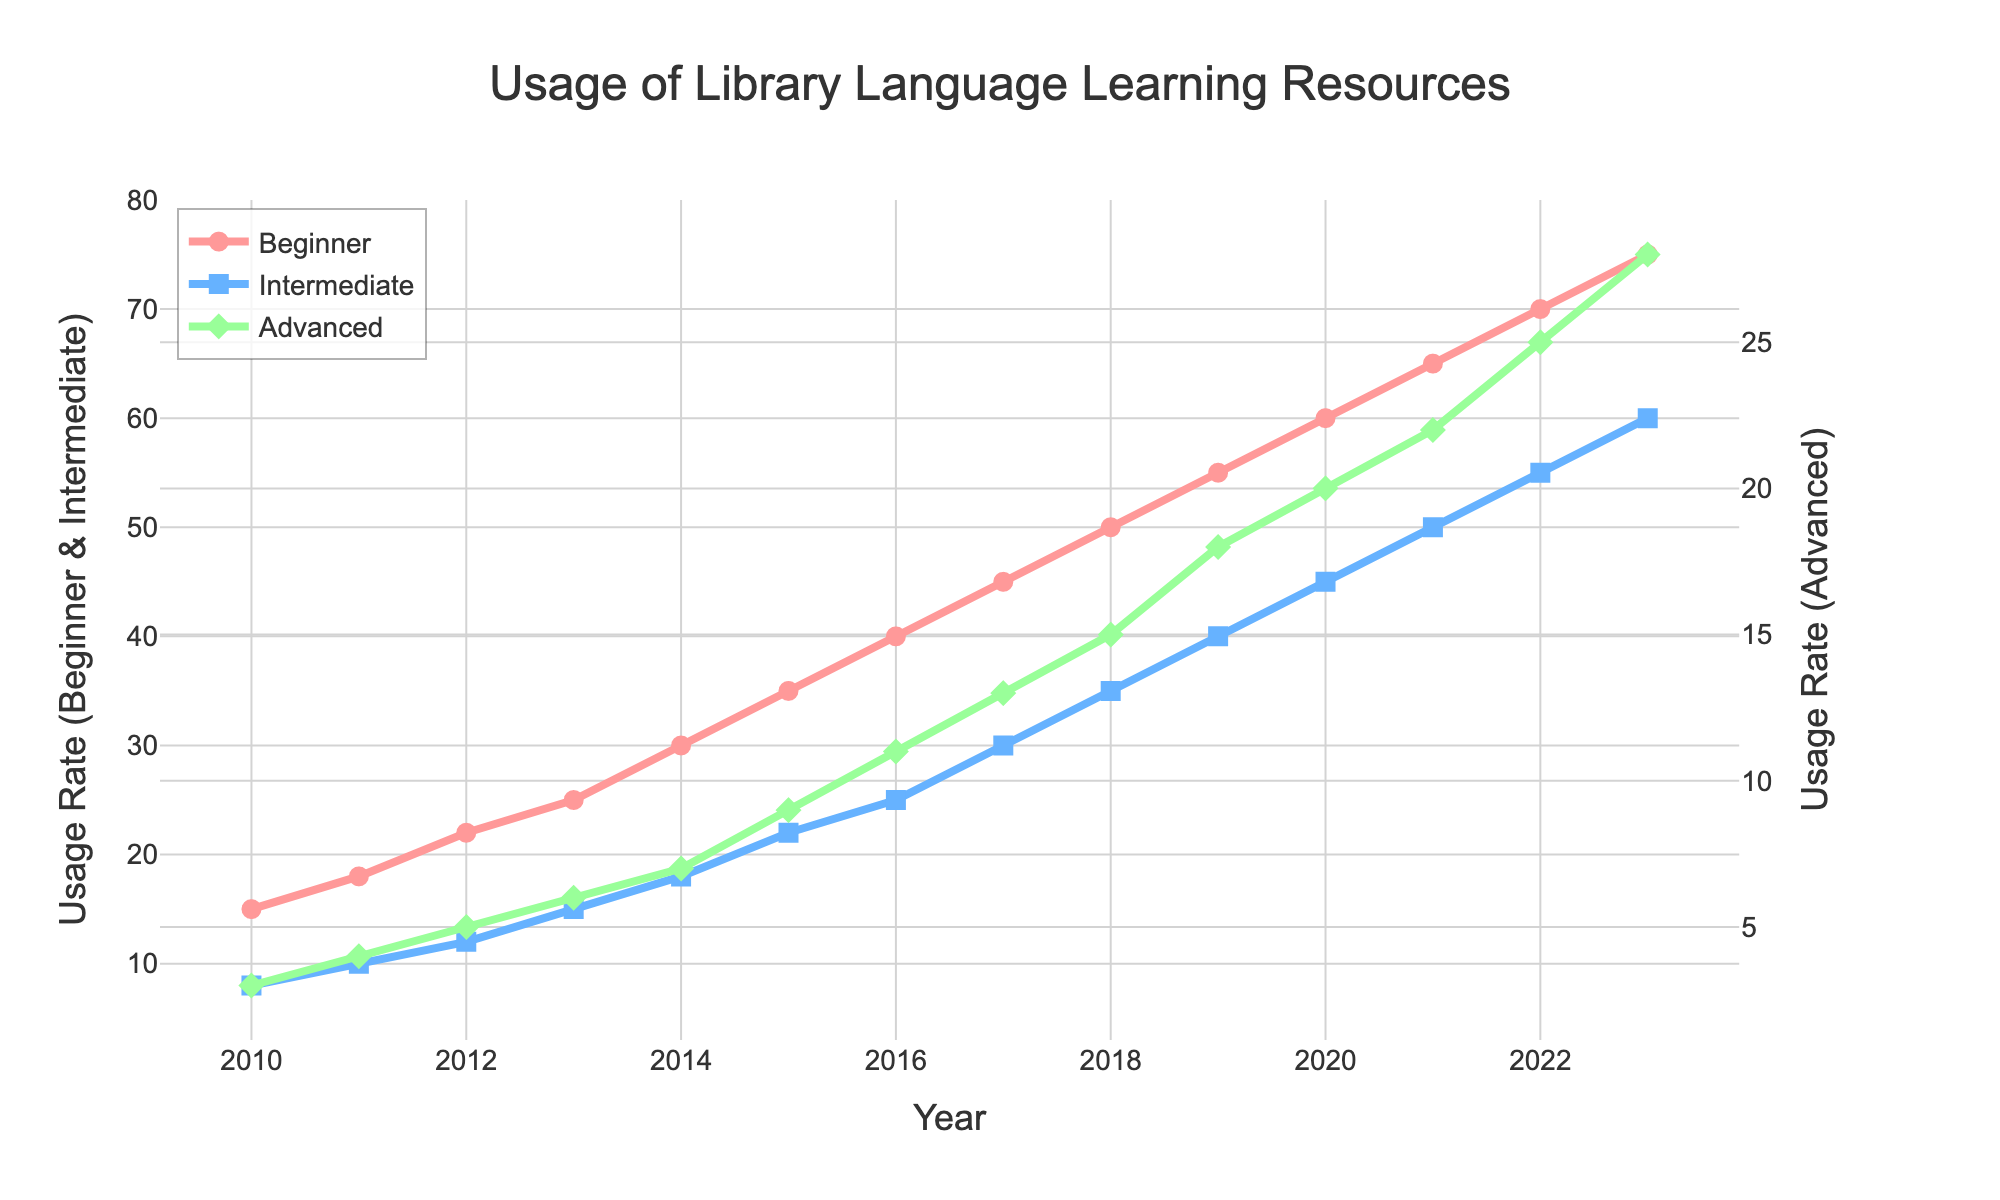What trend is observed in the Beginner proficiency level from 2010 to 2023? The Beginner proficiency level shows a consistent increase from 2010 (with a usage rate of 15) to 2023 (with a usage rate of 75).
Answer: Consistent increase Which year shows the highest usage rate for the Intermediate proficiency level? The year 2023 shows the highest usage rate for the Intermediate proficiency level, reaching 60.
Answer: 2023 How does the usage rate of the Advanced proficiency level in 2023 compare to that in 2010? The usage rate of the Advanced proficiency level in 2023 is 28, which is significantly higher than the usage rate in 2010, which was 3.
Answer: Significantly higher What is the difference in usage rates between the Beginner and Intermediate proficiency levels in 2020? In 2020, the usage rate for Beginner is 60 and for Intermediate is 45. The difference is 60 - 45 = 15.
Answer: 15 What are the average usage rates for Beginner and Intermediate proficiency levels across the entire period from 2010 to 2023? The sum of the Beginner usage rates over the period is 590. Dividing by 14 years gives an average of approximately 42.14. The sum of the Intermediate usage rates is 385, and the average is approximately 27.50.
Answer: Beginner: 42.14, Intermediate: 27.50 In which year did the Intermediate proficiency level first surpass a usage rate of 30? The Intermediate proficiency level first surpassed a usage rate of 30 in the year 2017.
Answer: 2017 By how much did the Advanced proficiency level usage rate increase between 2015 and 2023? The usage rate for Advanced in 2015 was 9, and in 2023 it was 28. The increase is 28 - 9 = 19.
Answer: 19 Which proficiency level has the sharpest increase in usage rate from 2010 to 2023? To determine the sharpest increase, we compare the usage rate changes: Beginner increased by 60 (75 - 15), Intermediate by 52 (60 - 8), and Advanced by 25 (28 - 3). The Beginner level has the sharpest increase.
Answer: Beginner In what way is the Advanced proficiency level visually represented differently from the Beginner and Intermediate levels on the chart? The Advanced proficiency level is represented with a green line and diamond markers, whereas the Beginner and Intermediate levels use red circles and blue squares, respectively.
Answer: Green line, diamond markers What was the sum of the usage rates for all three proficiency levels in 2012? In 2012, the usage rates were 22 for Beginner, 12 for Intermediate, and 5 for Advanced. The sum is 22 + 12 + 5 = 39.
Answer: 39 Which proficiency level shows more consistent growth without any visible dips from 2010 to 2023? The Beginner proficiency level shows consistent growth without any visible dips from 2010 to 2023.
Answer: Beginner 